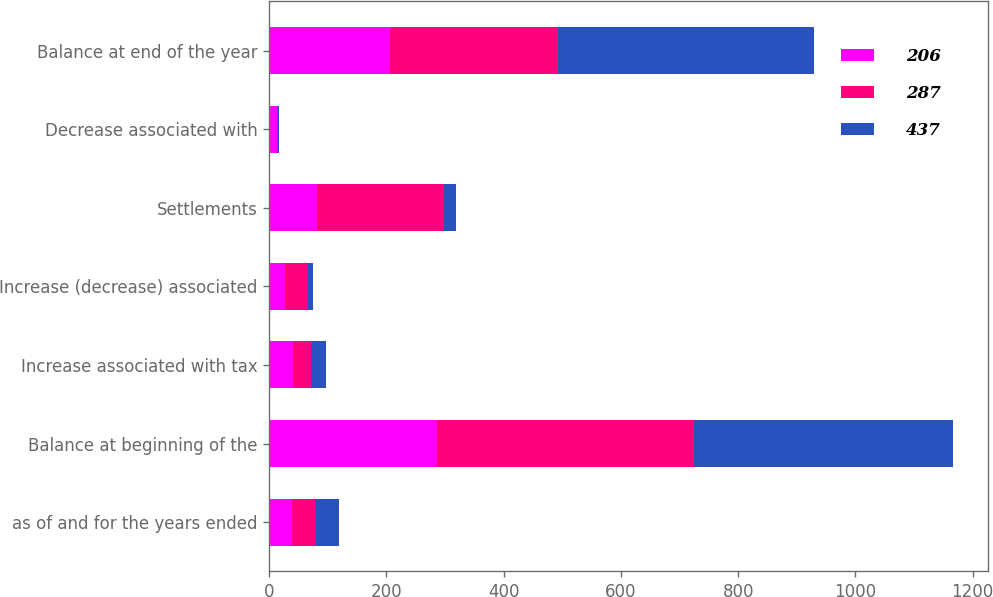Convert chart to OTSL. <chart><loc_0><loc_0><loc_500><loc_500><stacked_bar_chart><ecel><fcel>as of and for the years ended<fcel>Balance at beginning of the<fcel>Increase associated with tax<fcel>Increase (decrease) associated<fcel>Settlements<fcel>Decrease associated with<fcel>Balance at end of the year<nl><fcel>206<fcel>39.5<fcel>287<fcel>41<fcel>27<fcel>82<fcel>13<fcel>206<nl><fcel>287<fcel>39.5<fcel>437<fcel>31<fcel>38<fcel>216<fcel>3<fcel>287<nl><fcel>437<fcel>39.5<fcel>443<fcel>25<fcel>9<fcel>21<fcel>1<fcel>437<nl></chart> 